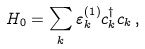<formula> <loc_0><loc_0><loc_500><loc_500>H _ { 0 } = \sum _ { k } \varepsilon ^ { ( 1 ) } _ { k } c _ { k } ^ { \dagger } c _ { k } \, ,</formula> 